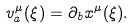Convert formula to latex. <formula><loc_0><loc_0><loc_500><loc_500>v _ { a } ^ { \mu } ( \xi ) = \partial _ { b } x ^ { \mu } ( \xi ) .</formula> 